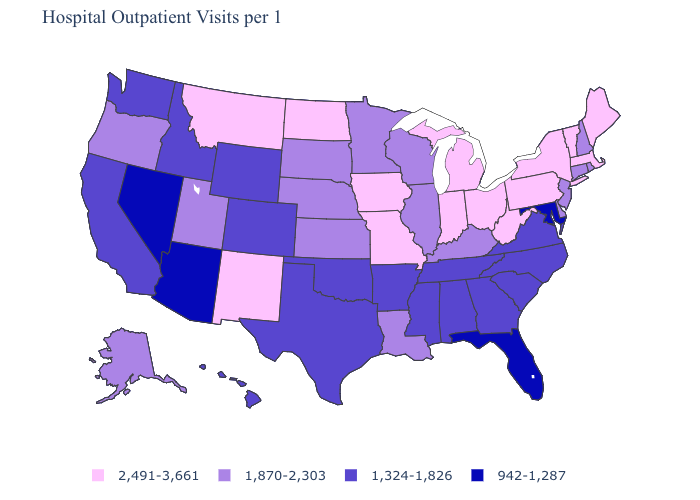What is the value of Florida?
Keep it brief. 942-1,287. Name the states that have a value in the range 1,870-2,303?
Answer briefly. Alaska, Connecticut, Delaware, Illinois, Kansas, Kentucky, Louisiana, Minnesota, Nebraska, New Hampshire, New Jersey, Oregon, Rhode Island, South Dakota, Utah, Wisconsin. What is the value of Tennessee?
Quick response, please. 1,324-1,826. Which states have the lowest value in the USA?
Answer briefly. Arizona, Florida, Maryland, Nevada. Does the map have missing data?
Quick response, please. No. Which states have the highest value in the USA?
Short answer required. Indiana, Iowa, Maine, Massachusetts, Michigan, Missouri, Montana, New Mexico, New York, North Dakota, Ohio, Pennsylvania, Vermont, West Virginia. What is the highest value in the West ?
Short answer required. 2,491-3,661. What is the highest value in states that border Montana?
Keep it brief. 2,491-3,661. Among the states that border Washington , which have the highest value?
Concise answer only. Oregon. Name the states that have a value in the range 942-1,287?
Short answer required. Arizona, Florida, Maryland, Nevada. What is the value of New Mexico?
Concise answer only. 2,491-3,661. Does New York have the highest value in the USA?
Be succinct. Yes. Does Nebraska have the highest value in the USA?
Give a very brief answer. No. Which states have the lowest value in the MidWest?
Concise answer only. Illinois, Kansas, Minnesota, Nebraska, South Dakota, Wisconsin. Among the states that border California , which have the lowest value?
Quick response, please. Arizona, Nevada. 